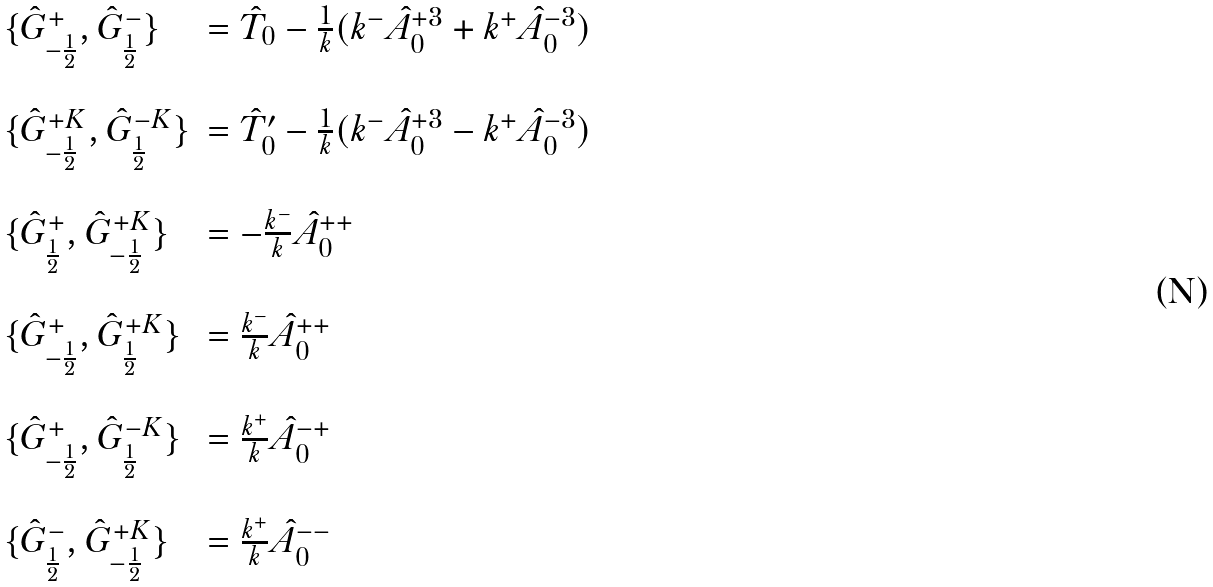<formula> <loc_0><loc_0><loc_500><loc_500>\begin{array} { l l } \{ \hat { G } ^ { + } _ { - \frac { 1 } { 2 } } , \hat { G } ^ { - } _ { \frac { 1 } { 2 } } \} & = \hat { T } _ { 0 } - \frac { 1 } { k } ( k ^ { - } \hat { A } ^ { + 3 } _ { 0 } + k ^ { + } \hat { A } ^ { - 3 } _ { 0 } ) \\ & \\ \{ \hat { G } ^ { + K } _ { - \frac { 1 } { 2 } } , \hat { G } ^ { - K } _ { \frac { 1 } { 2 } } \} & = \hat { T } ^ { \prime } _ { 0 } - \frac { 1 } { k } ( k ^ { - } \hat { A } ^ { + 3 } _ { 0 } - k ^ { + } \hat { A } ^ { - 3 } _ { 0 } ) \\ & \\ \{ \hat { G } ^ { + } _ { \frac { 1 } { 2 } } , \hat { G } ^ { + K } _ { - \frac { 1 } { 2 } } \} & = - \frac { k ^ { - } } { k } \hat { A } ^ { + + } _ { 0 } \\ & \\ \{ \hat { G } ^ { + } _ { - \frac { 1 } { 2 } } , \hat { G } ^ { + K } _ { \frac { 1 } { 2 } } \} & = \frac { k ^ { - } } { k } \hat { A } ^ { + + } _ { 0 } \\ & \\ \{ \hat { G } ^ { + } _ { - \frac { 1 } { 2 } } , \hat { G } ^ { - K } _ { \frac { 1 } { 2 } } \} & = \frac { k ^ { + } } { k } \hat { A } ^ { - + } _ { 0 } \\ & \\ \{ \hat { G } ^ { - } _ { \frac { 1 } { 2 } } , \hat { G } ^ { + K } _ { - \frac { 1 } { 2 } } \} & = \frac { k ^ { + } } { k } \hat { A } ^ { - - } _ { 0 } \end{array}</formula> 